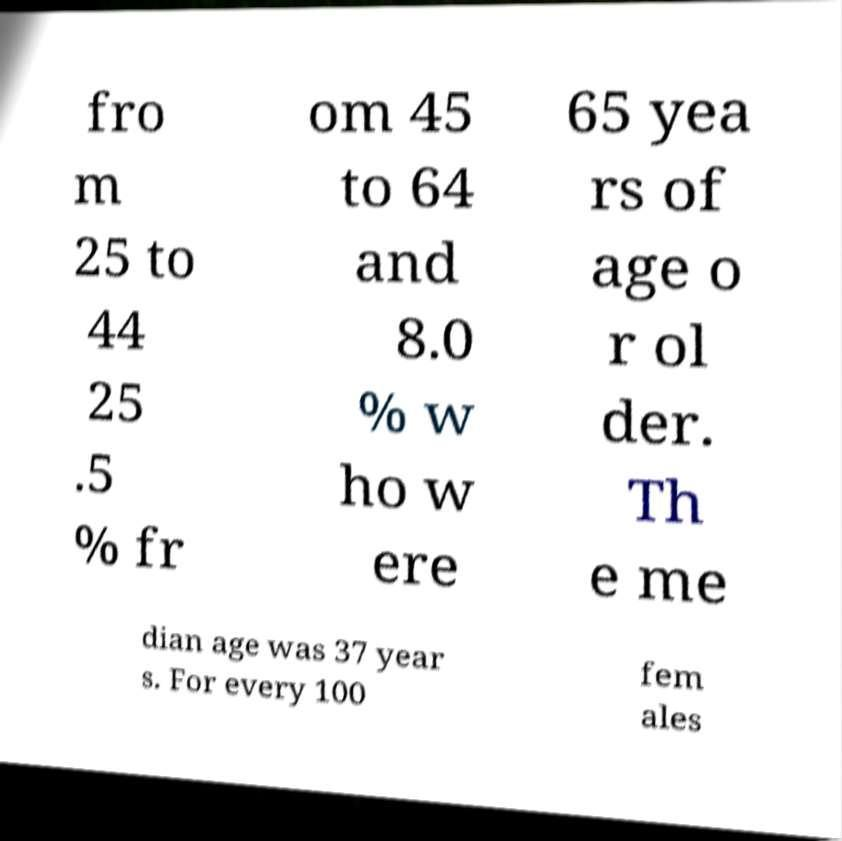Please identify and transcribe the text found in this image. fro m 25 to 44 25 .5 % fr om 45 to 64 and 8.0 % w ho w ere 65 yea rs of age o r ol der. Th e me dian age was 37 year s. For every 100 fem ales 